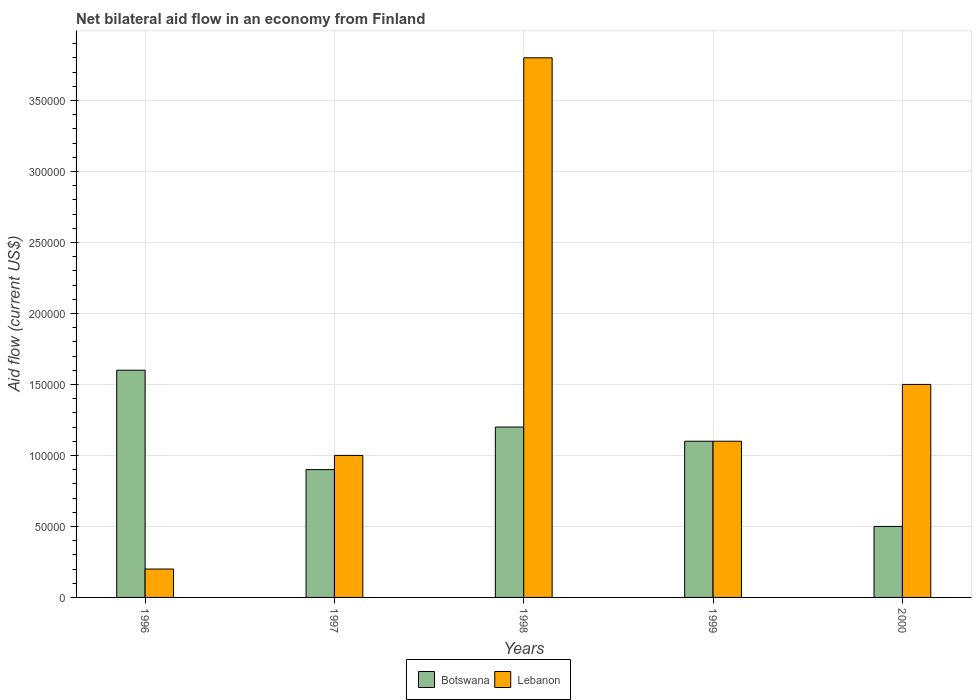How many groups of bars are there?
Make the answer very short. 5. How many bars are there on the 1st tick from the left?
Provide a succinct answer. 2. How many bars are there on the 2nd tick from the right?
Offer a very short reply. 2. In how many cases, is the number of bars for a given year not equal to the number of legend labels?
Your response must be concise. 0. Across all years, what is the maximum net bilateral aid flow in Lebanon?
Ensure brevity in your answer.  3.80e+05. Across all years, what is the minimum net bilateral aid flow in Lebanon?
Your answer should be very brief. 2.00e+04. What is the total net bilateral aid flow in Botswana in the graph?
Provide a short and direct response. 5.30e+05. What is the difference between the net bilateral aid flow in Botswana in 1996 and that in 1999?
Make the answer very short. 5.00e+04. What is the average net bilateral aid flow in Lebanon per year?
Give a very brief answer. 1.52e+05. In the year 2000, what is the difference between the net bilateral aid flow in Botswana and net bilateral aid flow in Lebanon?
Your answer should be very brief. -1.00e+05. Is the net bilateral aid flow in Botswana in 1996 less than that in 1999?
Offer a terse response. No. Is the difference between the net bilateral aid flow in Botswana in 1998 and 1999 greater than the difference between the net bilateral aid flow in Lebanon in 1998 and 1999?
Your answer should be very brief. No. What is the difference between the highest and the lowest net bilateral aid flow in Lebanon?
Give a very brief answer. 3.60e+05. In how many years, is the net bilateral aid flow in Lebanon greater than the average net bilateral aid flow in Lebanon taken over all years?
Give a very brief answer. 1. What does the 2nd bar from the left in 1997 represents?
Offer a terse response. Lebanon. What does the 1st bar from the right in 1998 represents?
Your answer should be compact. Lebanon. Are all the bars in the graph horizontal?
Provide a short and direct response. No. How many years are there in the graph?
Your answer should be very brief. 5. Does the graph contain grids?
Offer a terse response. Yes. What is the title of the graph?
Your answer should be very brief. Net bilateral aid flow in an economy from Finland. What is the Aid flow (current US$) of Botswana in 1996?
Offer a terse response. 1.60e+05. What is the Aid flow (current US$) of Lebanon in 1999?
Offer a very short reply. 1.10e+05. Across all years, what is the maximum Aid flow (current US$) in Lebanon?
Ensure brevity in your answer.  3.80e+05. Across all years, what is the minimum Aid flow (current US$) of Lebanon?
Your answer should be very brief. 2.00e+04. What is the total Aid flow (current US$) of Botswana in the graph?
Your response must be concise. 5.30e+05. What is the total Aid flow (current US$) of Lebanon in the graph?
Your answer should be compact. 7.60e+05. What is the difference between the Aid flow (current US$) in Botswana in 1996 and that in 1997?
Provide a succinct answer. 7.00e+04. What is the difference between the Aid flow (current US$) of Lebanon in 1996 and that in 1998?
Offer a terse response. -3.60e+05. What is the difference between the Aid flow (current US$) in Lebanon in 1996 and that in 2000?
Offer a very short reply. -1.30e+05. What is the difference between the Aid flow (current US$) of Lebanon in 1997 and that in 1998?
Your response must be concise. -2.80e+05. What is the difference between the Aid flow (current US$) in Lebanon in 1998 and that in 1999?
Ensure brevity in your answer.  2.70e+05. What is the difference between the Aid flow (current US$) of Botswana in 1998 and that in 2000?
Offer a very short reply. 7.00e+04. What is the difference between the Aid flow (current US$) of Lebanon in 1998 and that in 2000?
Offer a terse response. 2.30e+05. What is the difference between the Aid flow (current US$) of Lebanon in 1999 and that in 2000?
Provide a short and direct response. -4.00e+04. What is the difference between the Aid flow (current US$) of Botswana in 1996 and the Aid flow (current US$) of Lebanon in 1998?
Offer a terse response. -2.20e+05. What is the difference between the Aid flow (current US$) in Botswana in 1996 and the Aid flow (current US$) in Lebanon in 2000?
Your answer should be compact. 10000. What is the difference between the Aid flow (current US$) in Botswana in 1997 and the Aid flow (current US$) in Lebanon in 1998?
Offer a terse response. -2.90e+05. What is the difference between the Aid flow (current US$) in Botswana in 1997 and the Aid flow (current US$) in Lebanon in 1999?
Offer a very short reply. -2.00e+04. What is the difference between the Aid flow (current US$) in Botswana in 1998 and the Aid flow (current US$) in Lebanon in 1999?
Ensure brevity in your answer.  10000. What is the difference between the Aid flow (current US$) in Botswana in 1999 and the Aid flow (current US$) in Lebanon in 2000?
Your answer should be very brief. -4.00e+04. What is the average Aid flow (current US$) of Botswana per year?
Make the answer very short. 1.06e+05. What is the average Aid flow (current US$) in Lebanon per year?
Provide a short and direct response. 1.52e+05. In the year 1998, what is the difference between the Aid flow (current US$) in Botswana and Aid flow (current US$) in Lebanon?
Ensure brevity in your answer.  -2.60e+05. In the year 1999, what is the difference between the Aid flow (current US$) of Botswana and Aid flow (current US$) of Lebanon?
Your response must be concise. 0. What is the ratio of the Aid flow (current US$) in Botswana in 1996 to that in 1997?
Offer a very short reply. 1.78. What is the ratio of the Aid flow (current US$) in Lebanon in 1996 to that in 1997?
Your response must be concise. 0.2. What is the ratio of the Aid flow (current US$) in Botswana in 1996 to that in 1998?
Your answer should be compact. 1.33. What is the ratio of the Aid flow (current US$) in Lebanon in 1996 to that in 1998?
Your answer should be very brief. 0.05. What is the ratio of the Aid flow (current US$) in Botswana in 1996 to that in 1999?
Your answer should be compact. 1.45. What is the ratio of the Aid flow (current US$) of Lebanon in 1996 to that in 1999?
Your answer should be very brief. 0.18. What is the ratio of the Aid flow (current US$) in Lebanon in 1996 to that in 2000?
Make the answer very short. 0.13. What is the ratio of the Aid flow (current US$) in Lebanon in 1997 to that in 1998?
Give a very brief answer. 0.26. What is the ratio of the Aid flow (current US$) in Botswana in 1997 to that in 1999?
Your answer should be very brief. 0.82. What is the ratio of the Aid flow (current US$) in Lebanon in 1997 to that in 1999?
Keep it short and to the point. 0.91. What is the ratio of the Aid flow (current US$) of Botswana in 1997 to that in 2000?
Your answer should be very brief. 1.8. What is the ratio of the Aid flow (current US$) in Botswana in 1998 to that in 1999?
Give a very brief answer. 1.09. What is the ratio of the Aid flow (current US$) of Lebanon in 1998 to that in 1999?
Your response must be concise. 3.45. What is the ratio of the Aid flow (current US$) in Botswana in 1998 to that in 2000?
Your response must be concise. 2.4. What is the ratio of the Aid flow (current US$) in Lebanon in 1998 to that in 2000?
Offer a terse response. 2.53. What is the ratio of the Aid flow (current US$) of Lebanon in 1999 to that in 2000?
Keep it short and to the point. 0.73. 